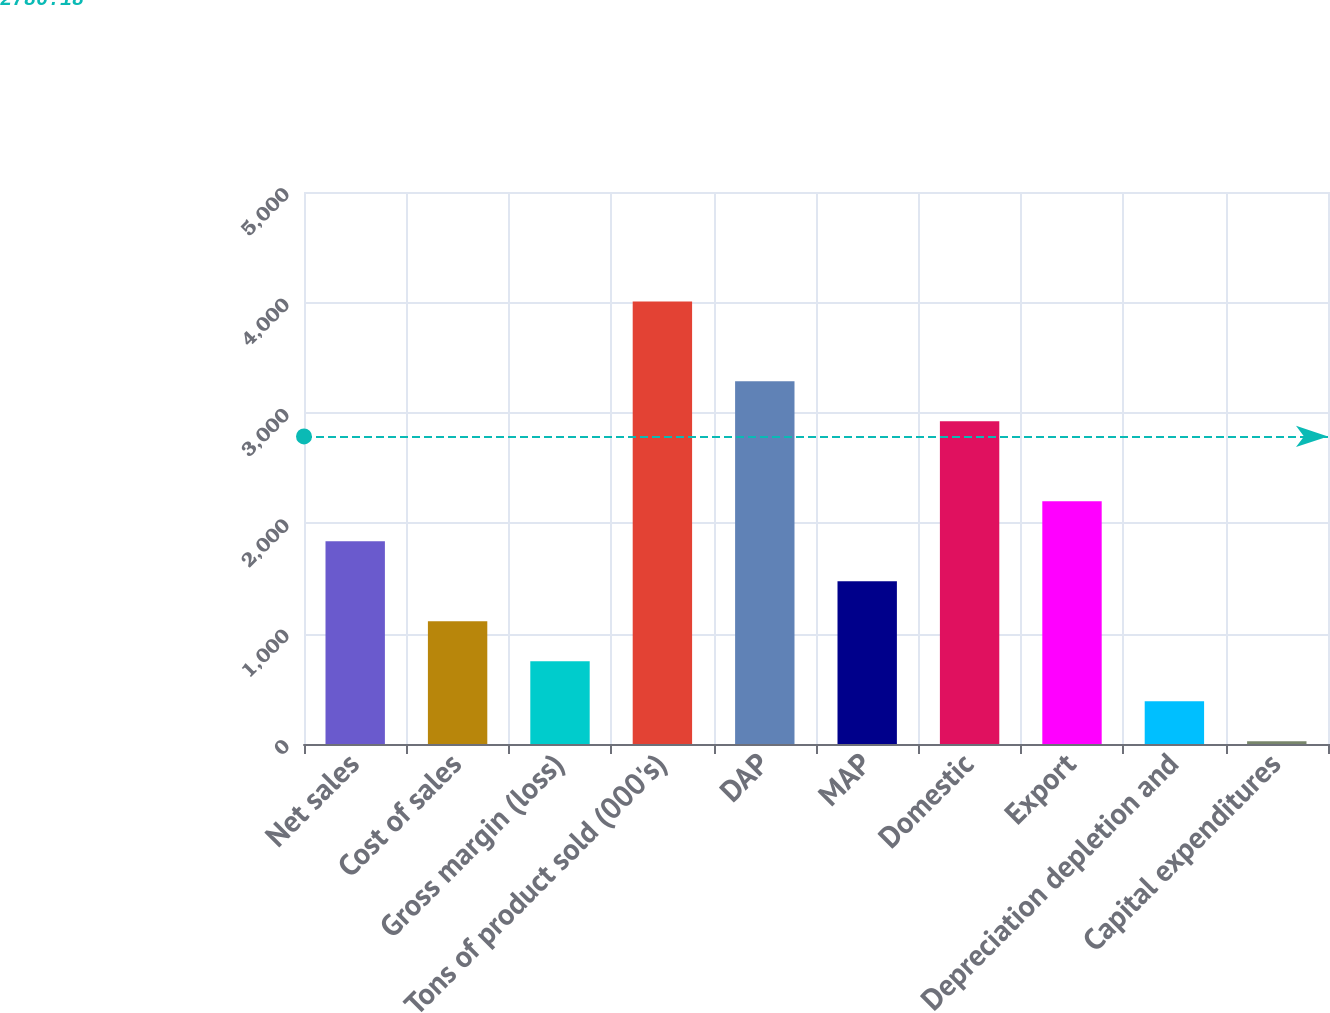<chart> <loc_0><loc_0><loc_500><loc_500><bar_chart><fcel>Net sales<fcel>Cost of sales<fcel>Gross margin (loss)<fcel>Tons of product sold (000's)<fcel>DAP<fcel>MAP<fcel>Domestic<fcel>Export<fcel>Depreciation depletion and<fcel>Capital expenditures<nl><fcel>1836.3<fcel>1112.02<fcel>749.88<fcel>4009.14<fcel>3284.86<fcel>1474.16<fcel>2922.72<fcel>2198.44<fcel>387.74<fcel>25.6<nl></chart> 